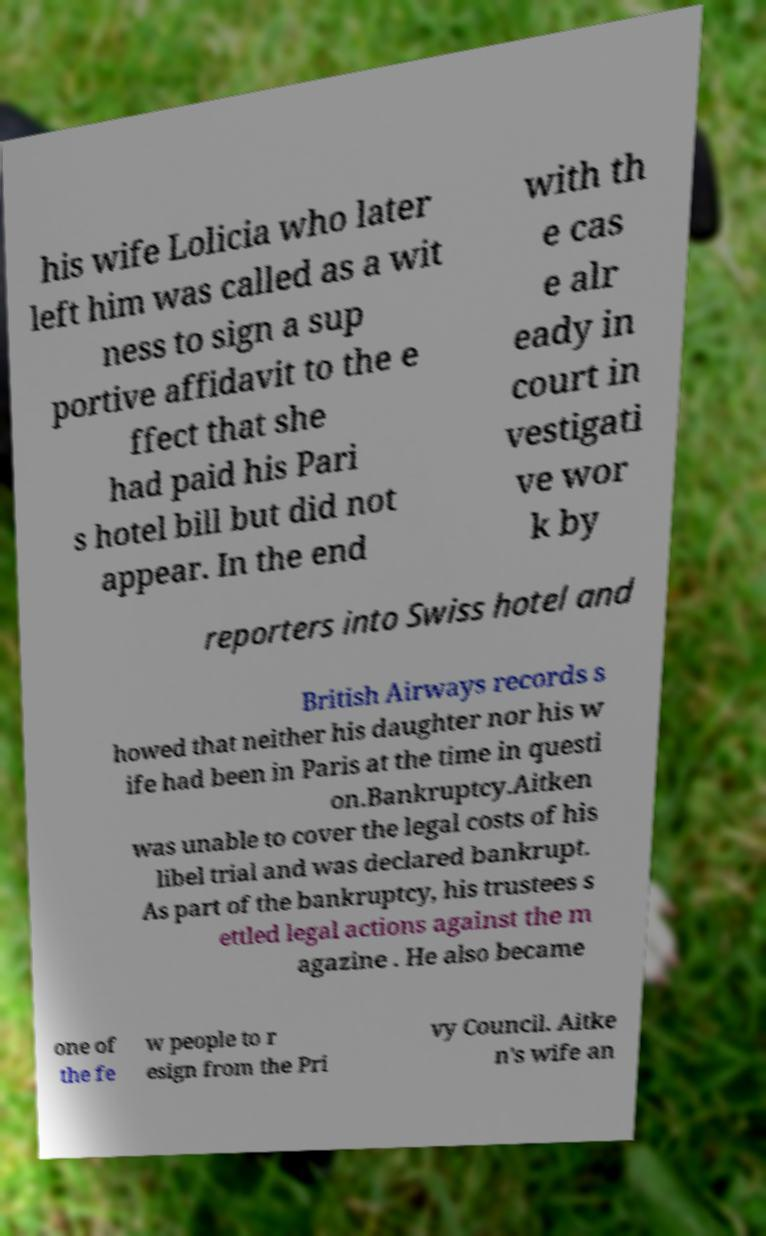Could you assist in decoding the text presented in this image and type it out clearly? his wife Lolicia who later left him was called as a wit ness to sign a sup portive affidavit to the e ffect that she had paid his Pari s hotel bill but did not appear. In the end with th e cas e alr eady in court in vestigati ve wor k by reporters into Swiss hotel and British Airways records s howed that neither his daughter nor his w ife had been in Paris at the time in questi on.Bankruptcy.Aitken was unable to cover the legal costs of his libel trial and was declared bankrupt. As part of the bankruptcy, his trustees s ettled legal actions against the m agazine . He also became one of the fe w people to r esign from the Pri vy Council. Aitke n's wife an 